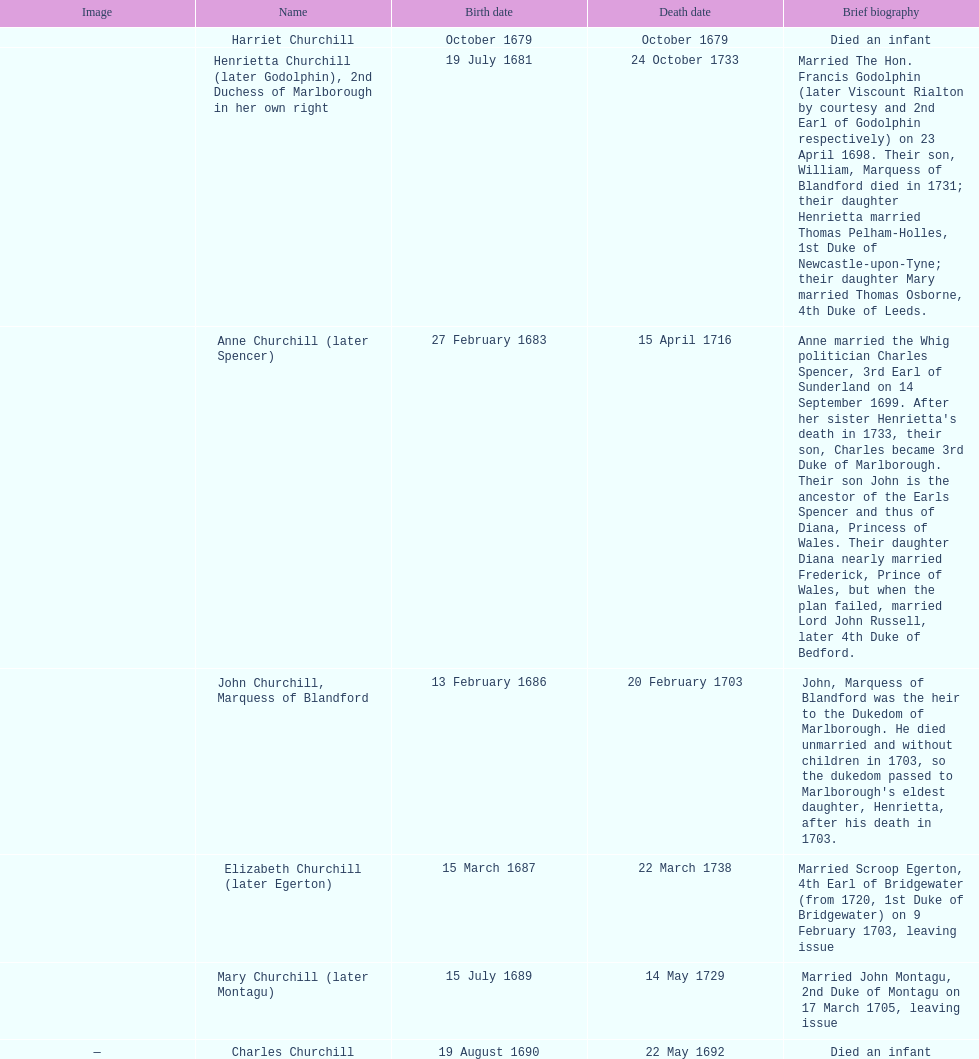Can you give me this table as a dict? {'header': ['Image', 'Name', 'Birth date', 'Death date', 'Brief biography'], 'rows': [['', 'Harriet Churchill', 'October 1679', 'October 1679', 'Died an infant'], ['', 'Henrietta Churchill (later Godolphin), 2nd Duchess of Marlborough in her own right', '19 July 1681', '24 October 1733', 'Married The Hon. Francis Godolphin (later Viscount Rialton by courtesy and 2nd Earl of Godolphin respectively) on 23 April 1698. Their son, William, Marquess of Blandford died in 1731; their daughter Henrietta married Thomas Pelham-Holles, 1st Duke of Newcastle-upon-Tyne; their daughter Mary married Thomas Osborne, 4th Duke of Leeds.'], ['', 'Anne Churchill (later Spencer)', '27 February 1683', '15 April 1716', "Anne married the Whig politician Charles Spencer, 3rd Earl of Sunderland on 14 September 1699. After her sister Henrietta's death in 1733, their son, Charles became 3rd Duke of Marlborough. Their son John is the ancestor of the Earls Spencer and thus of Diana, Princess of Wales. Their daughter Diana nearly married Frederick, Prince of Wales, but when the plan failed, married Lord John Russell, later 4th Duke of Bedford."], ['', 'John Churchill, Marquess of Blandford', '13 February 1686', '20 February 1703', "John, Marquess of Blandford was the heir to the Dukedom of Marlborough. He died unmarried and without children in 1703, so the dukedom passed to Marlborough's eldest daughter, Henrietta, after his death in 1703."], ['', 'Elizabeth Churchill (later Egerton)', '15 March 1687', '22 March 1738', 'Married Scroop Egerton, 4th Earl of Bridgewater (from 1720, 1st Duke of Bridgewater) on 9 February 1703, leaving issue'], ['', 'Mary Churchill (later Montagu)', '15 July 1689', '14 May 1729', 'Married John Montagu, 2nd Duke of Montagu on 17 March 1705, leaving issue'], ['—', 'Charles Churchill', '19 August 1690', '22 May 1692', 'Died an infant']]} What is the number of children sarah churchill had? 7. 